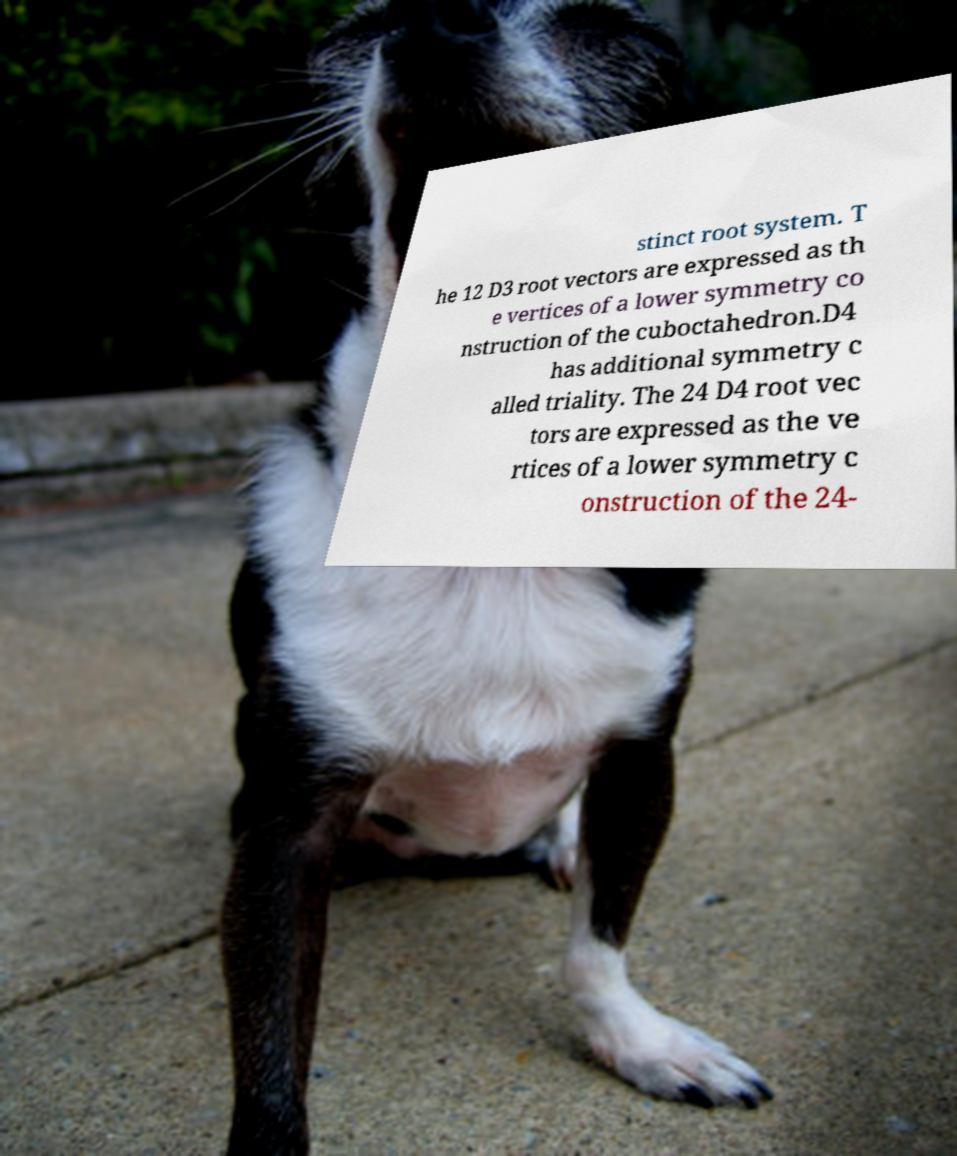What messages or text are displayed in this image? I need them in a readable, typed format. stinct root system. T he 12 D3 root vectors are expressed as th e vertices of a lower symmetry co nstruction of the cuboctahedron.D4 has additional symmetry c alled triality. The 24 D4 root vec tors are expressed as the ve rtices of a lower symmetry c onstruction of the 24- 